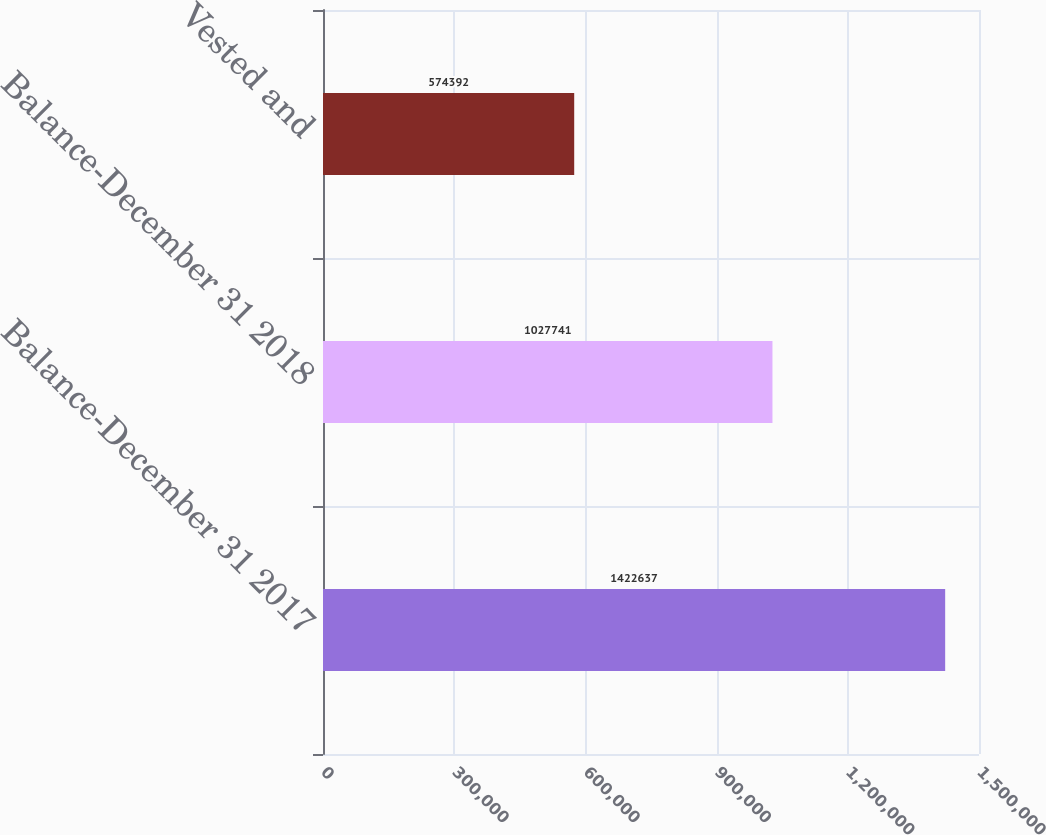<chart> <loc_0><loc_0><loc_500><loc_500><bar_chart><fcel>Balance-December 31 2017<fcel>Balance-December 31 2018<fcel>Vested and<nl><fcel>1.42264e+06<fcel>1.02774e+06<fcel>574392<nl></chart> 